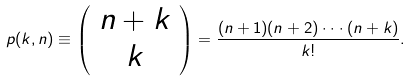Convert formula to latex. <formula><loc_0><loc_0><loc_500><loc_500>p ( k , n ) \equiv \left ( \begin{array} { c } n + k \\ k \end{array} \right ) = \frac { ( n + 1 ) ( n + 2 ) \cdot \cdot \cdot ( n + k ) } { k ! } .</formula> 